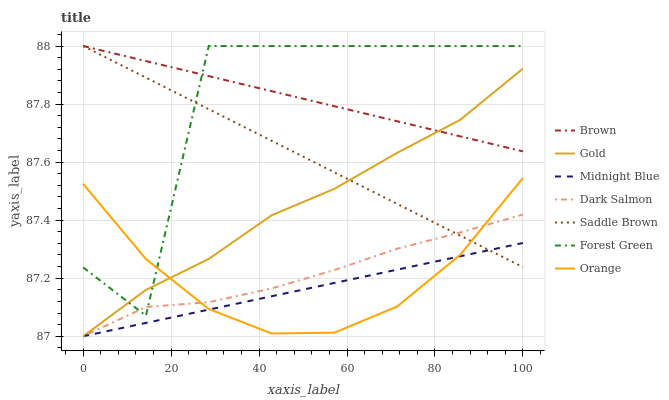Does Midnight Blue have the minimum area under the curve?
Answer yes or no. Yes. Does Brown have the maximum area under the curve?
Answer yes or no. Yes. Does Gold have the minimum area under the curve?
Answer yes or no. No. Does Gold have the maximum area under the curve?
Answer yes or no. No. Is Midnight Blue the smoothest?
Answer yes or no. Yes. Is Forest Green the roughest?
Answer yes or no. Yes. Is Gold the smoothest?
Answer yes or no. No. Is Gold the roughest?
Answer yes or no. No. Does Forest Green have the lowest value?
Answer yes or no. No. Does Saddle Brown have the highest value?
Answer yes or no. Yes. Does Gold have the highest value?
Answer yes or no. No. Is Orange less than Brown?
Answer yes or no. Yes. Is Brown greater than Orange?
Answer yes or no. Yes. Does Saddle Brown intersect Gold?
Answer yes or no. Yes. Is Saddle Brown less than Gold?
Answer yes or no. No. Is Saddle Brown greater than Gold?
Answer yes or no. No. Does Orange intersect Brown?
Answer yes or no. No. 